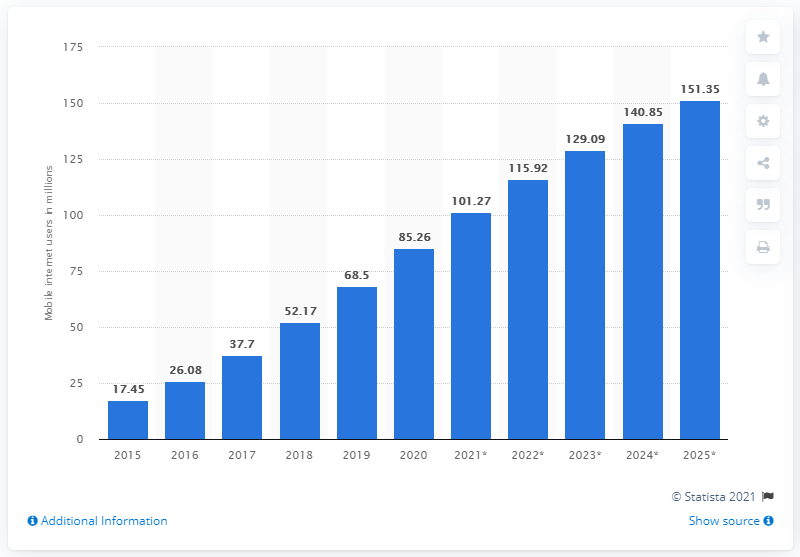List a handful of essential elements in this visual. By 2025, it is projected that the mobile internet audience in Nigeria will reach 151.35 million users. In 2015, the mobile internet audience in Nigeria was 17.45. In 2020, there were approximately 85.26 million mobile internet users in Nigeria. 